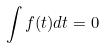Convert formula to latex. <formula><loc_0><loc_0><loc_500><loc_500>\int f ( t ) d t = 0</formula> 